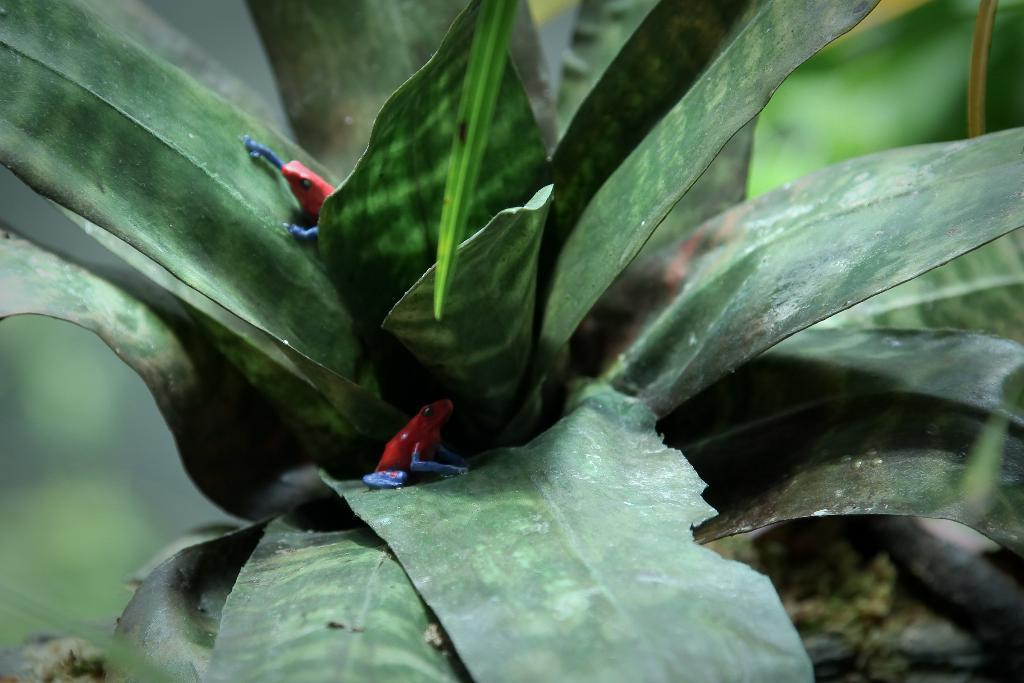What is the main subject of the image? There is a plant in the image. Are there any other living organisms on the plant? Yes, there are small frogs on the plant. Can you describe the background of the image? The background of the image is blurry. What type of guitar is the maid playing in the image? There is no guitar or maid present in the image; it features a plant with small frogs on it and a blurry background. 